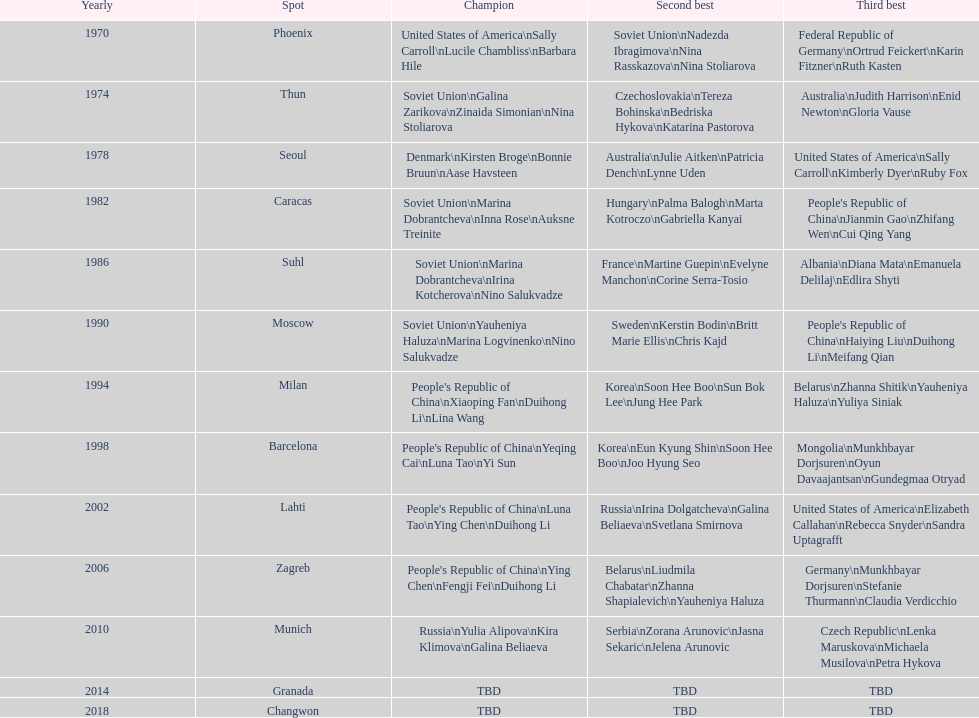Name one of the top three women to earn gold at the 1970 world championship held in phoenix, az Sally Carroll. 